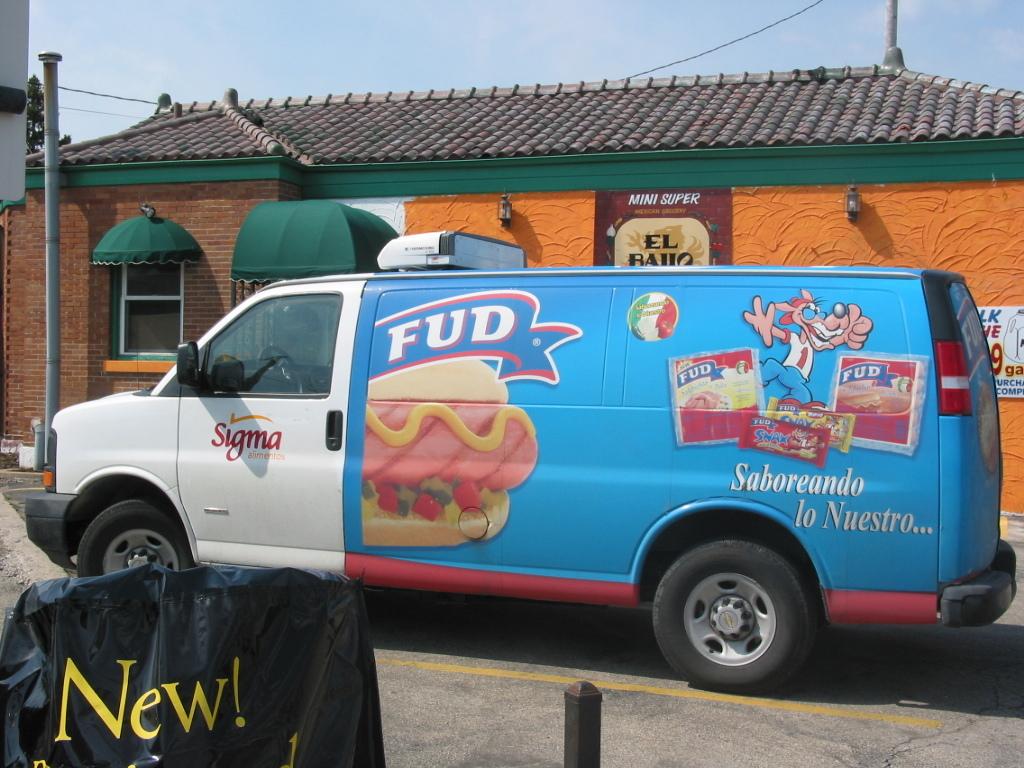What does it say on the left of the truck?
Your answer should be very brief. Sigma. What is the brand on the truck?
Ensure brevity in your answer.  Sigma. 